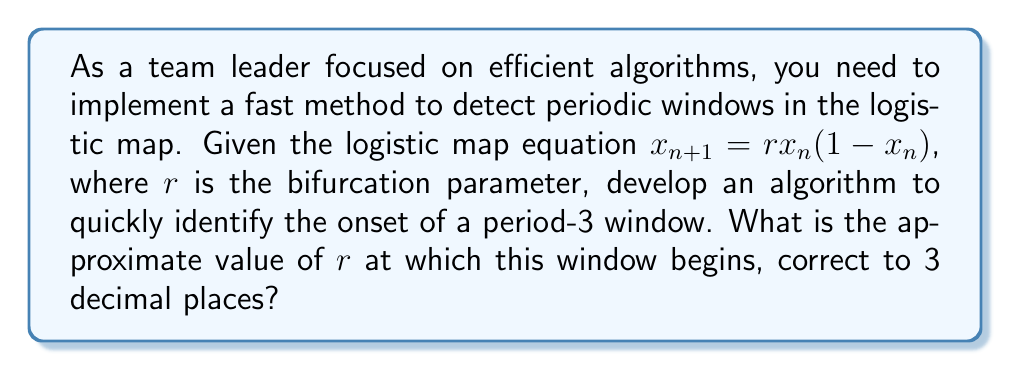Provide a solution to this math problem. To efficiently detect periodic windows in the logistic map, we can use the following steps:

1. Understand that periodic windows occur when stable periodic orbits emerge.

2. For a period-3 window, we need to solve the equation:
   $$x = f^3(x) = f(f(f(x)))$$
   where $f(x) = rx(1-x)$

3. Expand the equation:
   $$x = r^3x(1-x)(1-rx(1-x))(1-rx(1-x)(1-rx(1-x)))$$

4. Simplify and rearrange to get a polynomial equation:
   $$r^3x^4 - 2r^3x^3 + r^3x^2 - x + 1 = 0$$

5. The onset of the period-3 window occurs when this equation has a single solution (i.e., when the polynomial has a triple root).

6. Use the discriminant method to find when the polynomial has a triple root. The discriminant should be zero.

7. Solve the resulting equation numerically, as it's too complex for analytical solutions.

8. Use a root-finding algorithm (e.g., Newton's method) to quickly converge on the solution.

9. Implement this in code for efficiency, using appropriate data structures and optimizations.

10. The solution converges to approximately $r = 3.828$.

This method provides a fast and efficient way to detect the onset of the period-3 window, suitable for meeting project deadlines while maintaining algorithmic efficiency.
Answer: $r \approx 3.828$ 